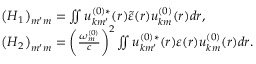Convert formula to latex. <formula><loc_0><loc_0><loc_500><loc_500>\begin{array} { r l } & { \left ( H _ { 1 } \right ) _ { m ^ { \prime } m } = \iint u _ { k m ^ { \prime } } ^ { ( 0 ) * } ( r ) \tilde { \varepsilon } ( r ) u _ { k m } ^ { ( 0 ) } ( r ) d r , } \\ & { \left ( H _ { 2 } \right ) _ { m ^ { \prime } m } = \left ( \frac { \omega _ { m } ^ { ( 0 ) } } { c } \right ) ^ { 2 } \iint u _ { k m ^ { \prime } } ^ { ( 0 ) * } ( r ) \varepsilon ( r ) u _ { k m } ^ { ( 0 ) } ( r ) d r . } \end{array}</formula> 